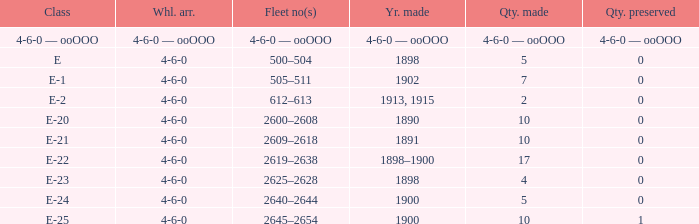What is the wheel arrangement made in 1890? 4-6-0. 